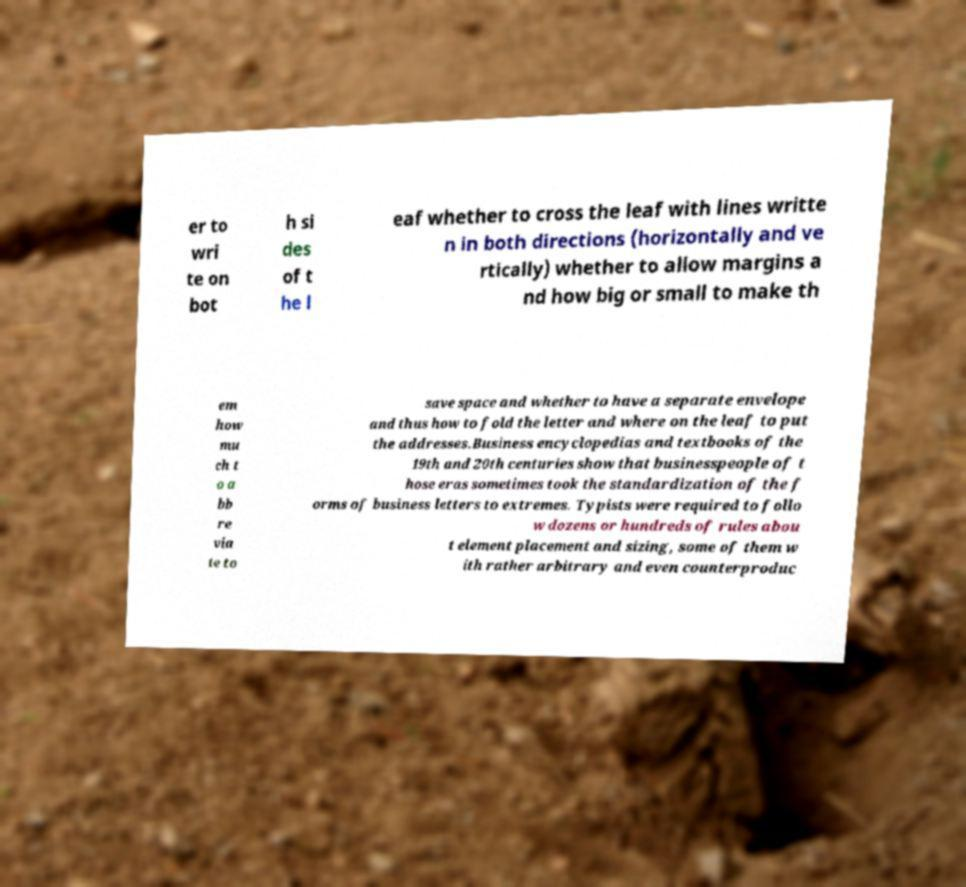I need the written content from this picture converted into text. Can you do that? er to wri te on bot h si des of t he l eaf whether to cross the leaf with lines writte n in both directions (horizontally and ve rtically) whether to allow margins a nd how big or small to make th em how mu ch t o a bb re via te to save space and whether to have a separate envelope and thus how to fold the letter and where on the leaf to put the addresses.Business encyclopedias and textbooks of the 19th and 20th centuries show that businesspeople of t hose eras sometimes took the standardization of the f orms of business letters to extremes. Typists were required to follo w dozens or hundreds of rules abou t element placement and sizing, some of them w ith rather arbitrary and even counterproduc 